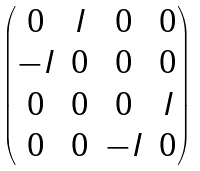Convert formula to latex. <formula><loc_0><loc_0><loc_500><loc_500>\begin{pmatrix} 0 & I & 0 & 0 \\ - I & 0 & 0 & 0 \\ 0 & 0 & 0 & I \\ 0 & 0 & - I & 0 \end{pmatrix}</formula> 